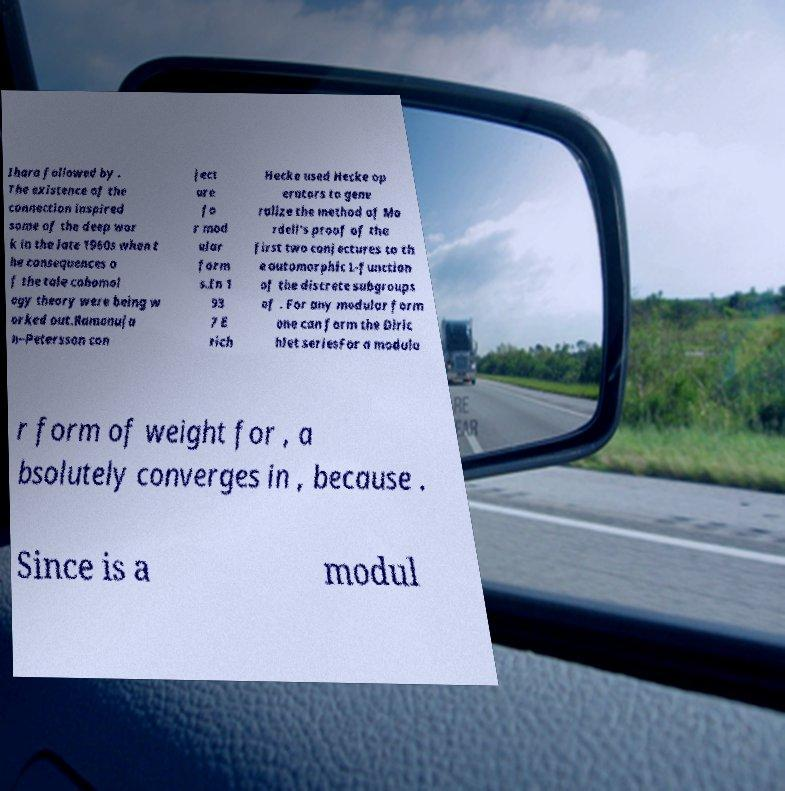Can you read and provide the text displayed in the image?This photo seems to have some interesting text. Can you extract and type it out for me? Ihara followed by . The existence of the connection inspired some of the deep wor k in the late 1960s when t he consequences o f the tale cohomol ogy theory were being w orked out.Ramanuja n–Petersson con ject ure fo r mod ular form s.In 1 93 7 E rich Hecke used Hecke op erators to gene ralize the method of Mo rdell's proof of the first two conjectures to th e automorphic L-function of the discrete subgroups of . For any modular form one can form the Diric hlet seriesFor a modula r form of weight for , a bsolutely converges in , because . Since is a modul 